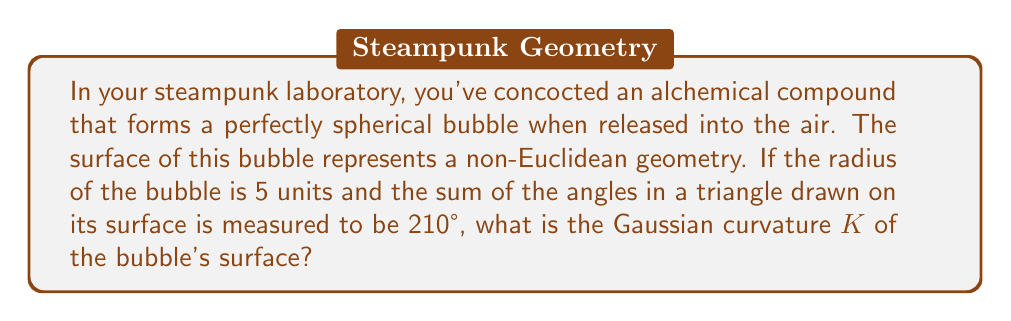Show me your answer to this math problem. Let's approach this step-by-step:

1) In non-Euclidean geometry, the sum of angles in a triangle is not always 180°. The difference from 180° is called the angular excess $\epsilon$:

   $\epsilon = (\text{sum of angles}) - 180°$

2) In this case:
   $\epsilon = 210° - 180° = 30° = \frac{\pi}{6}$ radians

3) For a sphere, the Gaussian curvature $K$ is constant over the entire surface and is related to the radius $R$ by:

   $K = \frac{1}{R^2}$

4) The Gauss-Bonnet theorem relates the angular excess to the Gaussian curvature and the area $A$ of the triangle:

   $\epsilon = KA$

5) For a sphere of radius $R$, the area $A$ of a triangle with angular excess $\epsilon$ is:

   $A = \frac{\epsilon R^2}{1}$

6) Substituting the known values:

   $\frac{\pi}{6} = K \cdot \frac{\pi}{6} R^2$

7) Simplifying:

   $1 = KR^2$

8) We know $R = 5$, so:

   $1 = K \cdot 5^2 = 25K$

9) Solving for $K$:

   $K = \frac{1}{25} = 0.04$

Therefore, the Gaussian curvature of the alchemical bubble's surface is 0.04 square units⁻¹.
Answer: $K = 0.04$ square units⁻¹ 